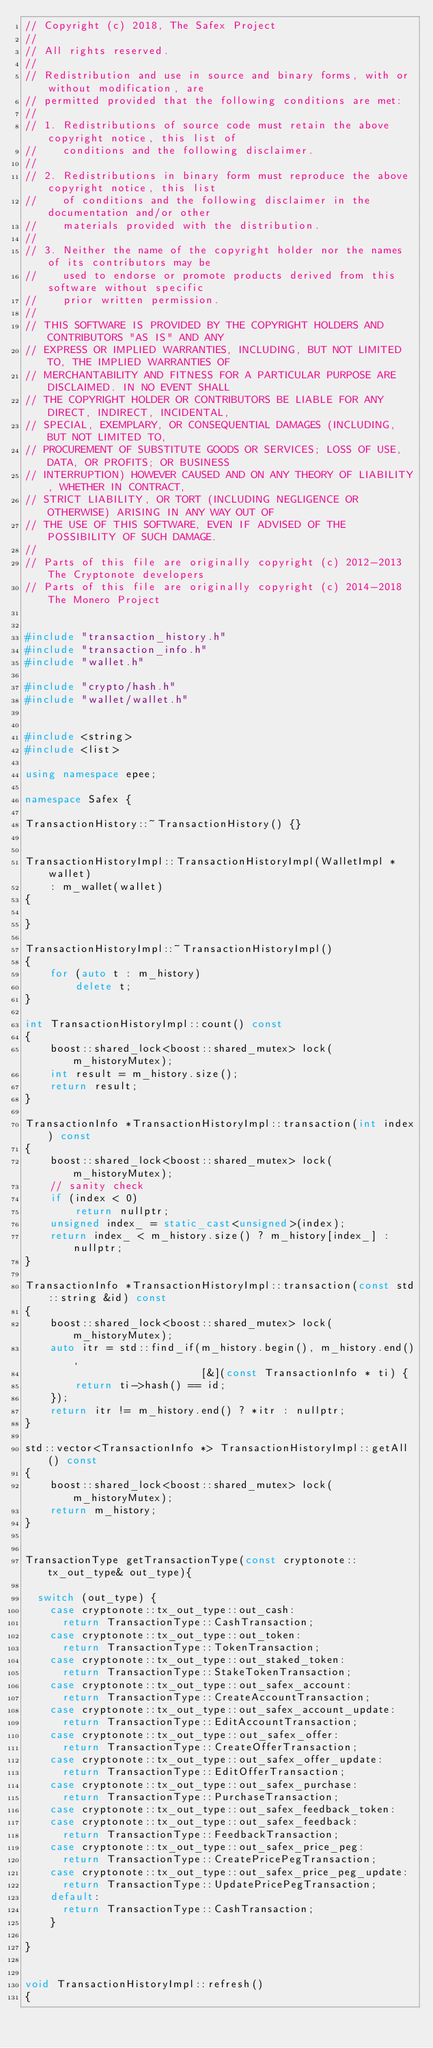<code> <loc_0><loc_0><loc_500><loc_500><_C++_>// Copyright (c) 2018, The Safex Project
//
// All rights reserved.
//
// Redistribution and use in source and binary forms, with or without modification, are
// permitted provided that the following conditions are met:
//
// 1. Redistributions of source code must retain the above copyright notice, this list of
//    conditions and the following disclaimer.
//
// 2. Redistributions in binary form must reproduce the above copyright notice, this list
//    of conditions and the following disclaimer in the documentation and/or other
//    materials provided with the distribution.
//
// 3. Neither the name of the copyright holder nor the names of its contributors may be
//    used to endorse or promote products derived from this software without specific
//    prior written permission.
//
// THIS SOFTWARE IS PROVIDED BY THE COPYRIGHT HOLDERS AND CONTRIBUTORS "AS IS" AND ANY
// EXPRESS OR IMPLIED WARRANTIES, INCLUDING, BUT NOT LIMITED TO, THE IMPLIED WARRANTIES OF
// MERCHANTABILITY AND FITNESS FOR A PARTICULAR PURPOSE ARE DISCLAIMED. IN NO EVENT SHALL
// THE COPYRIGHT HOLDER OR CONTRIBUTORS BE LIABLE FOR ANY DIRECT, INDIRECT, INCIDENTAL,
// SPECIAL, EXEMPLARY, OR CONSEQUENTIAL DAMAGES (INCLUDING, BUT NOT LIMITED TO,
// PROCUREMENT OF SUBSTITUTE GOODS OR SERVICES; LOSS OF USE, DATA, OR PROFITS; OR BUSINESS
// INTERRUPTION) HOWEVER CAUSED AND ON ANY THEORY OF LIABILITY, WHETHER IN CONTRACT,
// STRICT LIABILITY, OR TORT (INCLUDING NEGLIGENCE OR OTHERWISE) ARISING IN ANY WAY OUT OF
// THE USE OF THIS SOFTWARE, EVEN IF ADVISED OF THE POSSIBILITY OF SUCH DAMAGE.
//
// Parts of this file are originally copyright (c) 2012-2013 The Cryptonote developers
// Parts of this file are originally copyright (c) 2014-2018 The Monero Project


#include "transaction_history.h"
#include "transaction_info.h"
#include "wallet.h"

#include "crypto/hash.h"
#include "wallet/wallet.h"


#include <string>
#include <list>

using namespace epee;

namespace Safex {

TransactionHistory::~TransactionHistory() {}


TransactionHistoryImpl::TransactionHistoryImpl(WalletImpl *wallet)
    : m_wallet(wallet)
{

}

TransactionHistoryImpl::~TransactionHistoryImpl()
{
    for (auto t : m_history)
        delete t;
}

int TransactionHistoryImpl::count() const
{
    boost::shared_lock<boost::shared_mutex> lock(m_historyMutex);
    int result = m_history.size();
    return result;
}

TransactionInfo *TransactionHistoryImpl::transaction(int index) const
{
    boost::shared_lock<boost::shared_mutex> lock(m_historyMutex);
    // sanity check
    if (index < 0)
        return nullptr;
    unsigned index_ = static_cast<unsigned>(index);
    return index_ < m_history.size() ? m_history[index_] : nullptr;
}

TransactionInfo *TransactionHistoryImpl::transaction(const std::string &id) const
{
    boost::shared_lock<boost::shared_mutex> lock(m_historyMutex);
    auto itr = std::find_if(m_history.begin(), m_history.end(),
                            [&](const TransactionInfo * ti) {
        return ti->hash() == id;
    });
    return itr != m_history.end() ? *itr : nullptr;
}

std::vector<TransactionInfo *> TransactionHistoryImpl::getAll() const
{
    boost::shared_lock<boost::shared_mutex> lock(m_historyMutex);
    return m_history;
}


TransactionType getTransactionType(const cryptonote::tx_out_type& out_type){

  switch (out_type) {
    case cryptonote::tx_out_type::out_cash:
      return TransactionType::CashTransaction;
    case cryptonote::tx_out_type::out_token:
      return TransactionType::TokenTransaction;
    case cryptonote::tx_out_type::out_staked_token:
      return TransactionType::StakeTokenTransaction;
    case cryptonote::tx_out_type::out_safex_account:
      return TransactionType::CreateAccountTransaction;
    case cryptonote::tx_out_type::out_safex_account_update:
      return TransactionType::EditAccountTransaction;
    case cryptonote::tx_out_type::out_safex_offer:
      return TransactionType::CreateOfferTransaction;
    case cryptonote::tx_out_type::out_safex_offer_update:
      return TransactionType::EditOfferTransaction;
    case cryptonote::tx_out_type::out_safex_purchase:
      return TransactionType::PurchaseTransaction;
    case cryptonote::tx_out_type::out_safex_feedback_token:
    case cryptonote::tx_out_type::out_safex_feedback:
      return TransactionType::FeedbackTransaction;
    case cryptonote::tx_out_type::out_safex_price_peg:
      return TransactionType::CreatePricePegTransaction;
    case cryptonote::tx_out_type::out_safex_price_peg_update:
      return TransactionType::UpdatePricePegTransaction;
    default:
      return TransactionType::CashTransaction;
    }

}


void TransactionHistoryImpl::refresh()
{</code> 